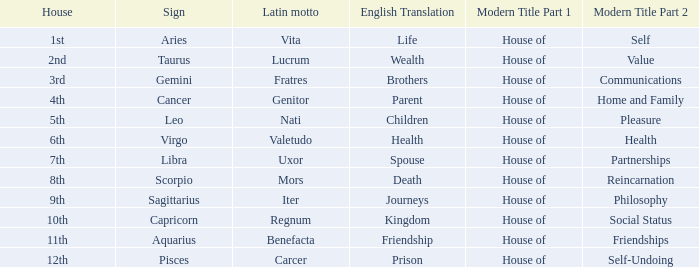What is the translation of the sign of Aquarius? Friendship. 